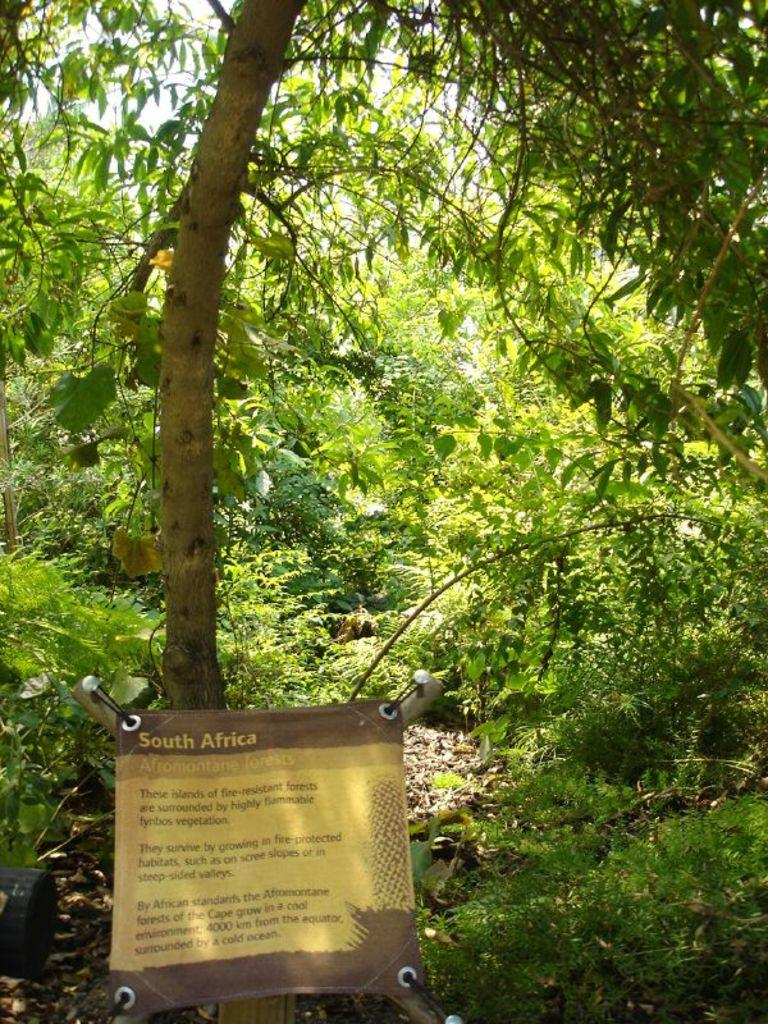What is attached to the tree in the image? There is a banner fixed to a tree in the image. What can be seen in the background of the image? There are many plants and trees in the background of the image. What is written on the banner? There is script on the banner. Can you see any jellyfish swimming in the image? No, there are no jellyfish present in the image. Who is the achiever mentioned on the banner in the image? The image does not provide any information about an achiever; it only shows a banner with script. 